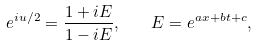Convert formula to latex. <formula><loc_0><loc_0><loc_500><loc_500>e ^ { i u / 2 } = \frac { 1 + i E } { 1 - i E } , \quad E = e ^ { a x + b t + c } ,</formula> 